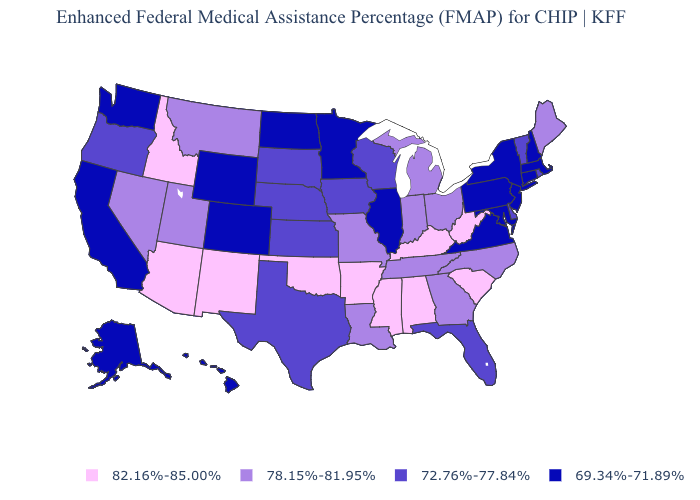Name the states that have a value in the range 78.15%-81.95%?
Be succinct. Georgia, Indiana, Louisiana, Maine, Michigan, Missouri, Montana, Nevada, North Carolina, Ohio, Tennessee, Utah. Name the states that have a value in the range 78.15%-81.95%?
Concise answer only. Georgia, Indiana, Louisiana, Maine, Michigan, Missouri, Montana, Nevada, North Carolina, Ohio, Tennessee, Utah. What is the highest value in the USA?
Answer briefly. 82.16%-85.00%. What is the lowest value in the USA?
Answer briefly. 69.34%-71.89%. Among the states that border Wisconsin , does Michigan have the highest value?
Answer briefly. Yes. Name the states that have a value in the range 72.76%-77.84%?
Write a very short answer. Delaware, Florida, Iowa, Kansas, Nebraska, Oregon, Rhode Island, South Dakota, Texas, Vermont, Wisconsin. What is the value of Kentucky?
Give a very brief answer. 82.16%-85.00%. Which states have the lowest value in the USA?
Answer briefly. Alaska, California, Colorado, Connecticut, Hawaii, Illinois, Maryland, Massachusetts, Minnesota, New Hampshire, New Jersey, New York, North Dakota, Pennsylvania, Virginia, Washington, Wyoming. Which states have the lowest value in the Northeast?
Short answer required. Connecticut, Massachusetts, New Hampshire, New Jersey, New York, Pennsylvania. Name the states that have a value in the range 72.76%-77.84%?
Give a very brief answer. Delaware, Florida, Iowa, Kansas, Nebraska, Oregon, Rhode Island, South Dakota, Texas, Vermont, Wisconsin. What is the value of Florida?
Be succinct. 72.76%-77.84%. What is the value of South Dakota?
Concise answer only. 72.76%-77.84%. What is the highest value in the Northeast ?
Short answer required. 78.15%-81.95%. Name the states that have a value in the range 69.34%-71.89%?
Give a very brief answer. Alaska, California, Colorado, Connecticut, Hawaii, Illinois, Maryland, Massachusetts, Minnesota, New Hampshire, New Jersey, New York, North Dakota, Pennsylvania, Virginia, Washington, Wyoming. Does Hawaii have the highest value in the West?
Write a very short answer. No. 